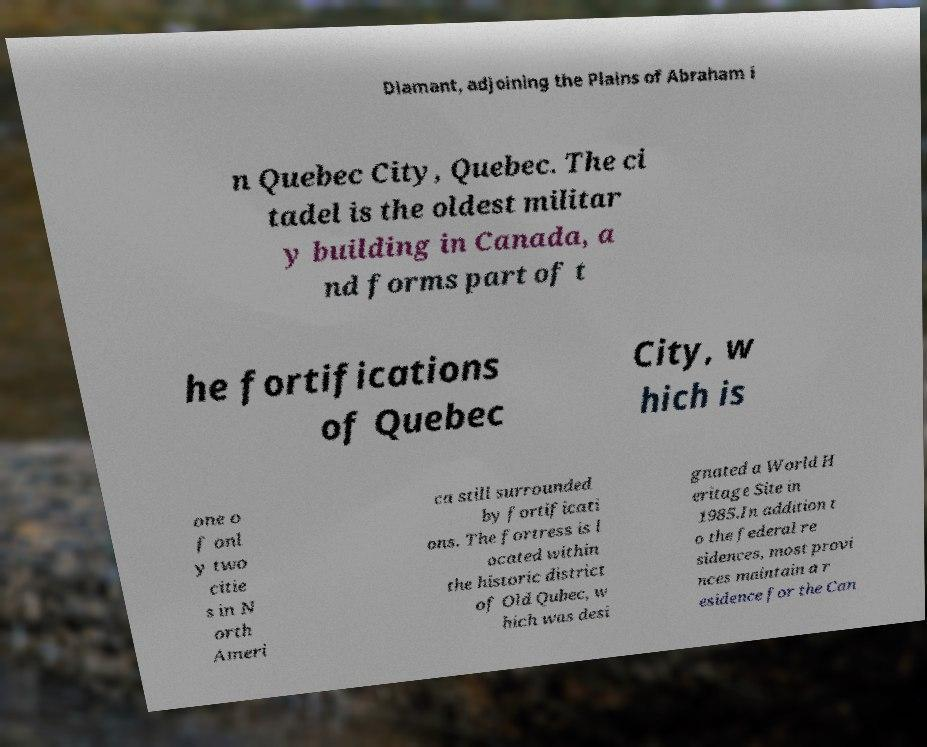Can you accurately transcribe the text from the provided image for me? Diamant, adjoining the Plains of Abraham i n Quebec City, Quebec. The ci tadel is the oldest militar y building in Canada, a nd forms part of t he fortifications of Quebec City, w hich is one o f onl y two citie s in N orth Ameri ca still surrounded by fortificati ons. The fortress is l ocated within the historic district of Old Qubec, w hich was desi gnated a World H eritage Site in 1985.In addition t o the federal re sidences, most provi nces maintain a r esidence for the Can 